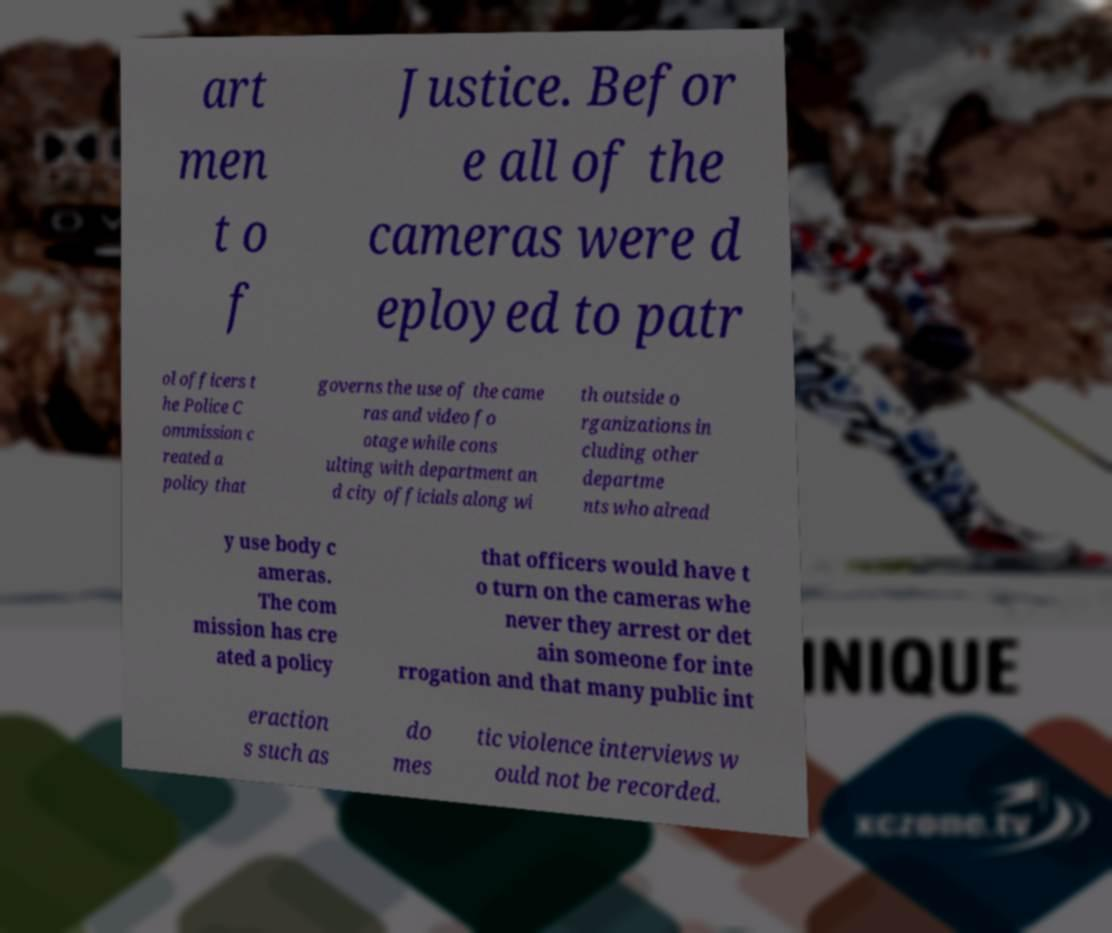Can you accurately transcribe the text from the provided image for me? art men t o f Justice. Befor e all of the cameras were d eployed to patr ol officers t he Police C ommission c reated a policy that governs the use of the came ras and video fo otage while cons ulting with department an d city officials along wi th outside o rganizations in cluding other departme nts who alread y use body c ameras. The com mission has cre ated a policy that officers would have t o turn on the cameras whe never they arrest or det ain someone for inte rrogation and that many public int eraction s such as do mes tic violence interviews w ould not be recorded. 